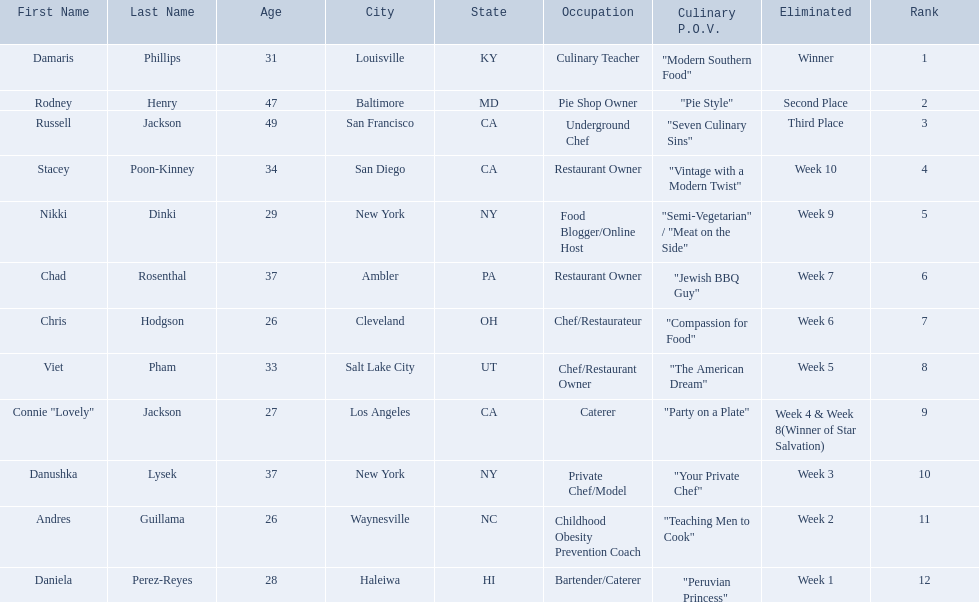Who are all of the people listed? Damaris Phillips, Rodney Henry, Russell Jackson, Stacey Poon-Kinney, Nikki Dinki, Chad Rosenthal, Chris Hodgson, Viet Pham, Connie "Lovely" Jackson, Danushka Lysek, Andres Guillama, Daniela Perez-Reyes. How old are they? 31, 47, 49, 34, 29, 37, 26, 33, 27, 37, 26, 28. Along with chris hodgson, which other person is 26 years old? Andres Guillama. 